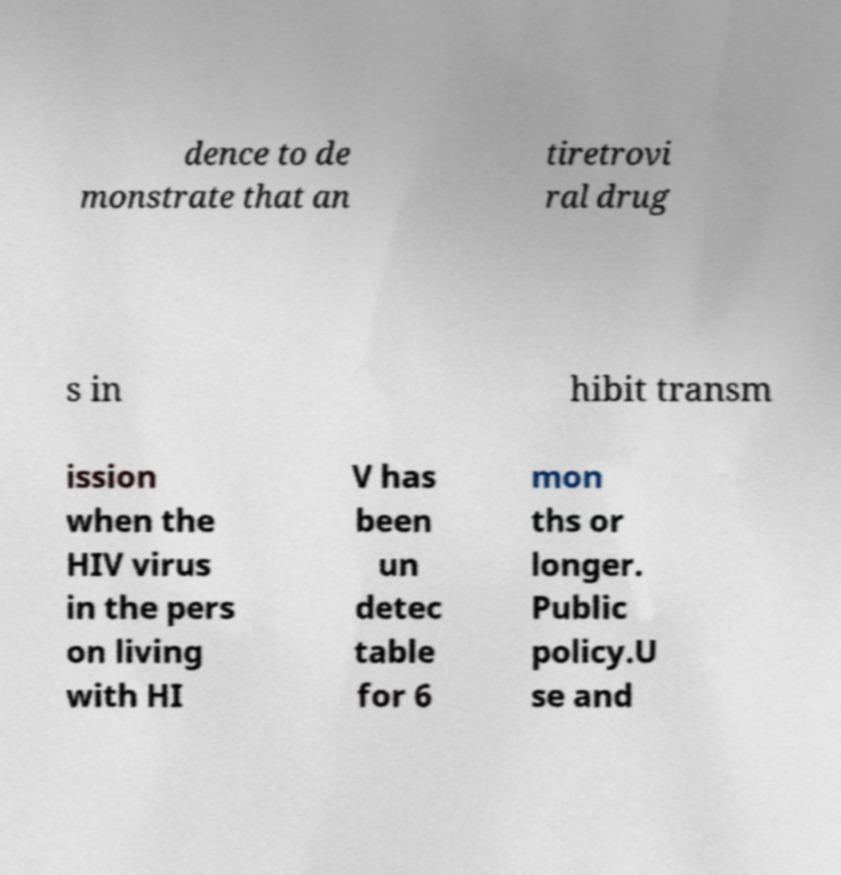There's text embedded in this image that I need extracted. Can you transcribe it verbatim? dence to de monstrate that an tiretrovi ral drug s in hibit transm ission when the HIV virus in the pers on living with HI V has been un detec table for 6 mon ths or longer. Public policy.U se and 